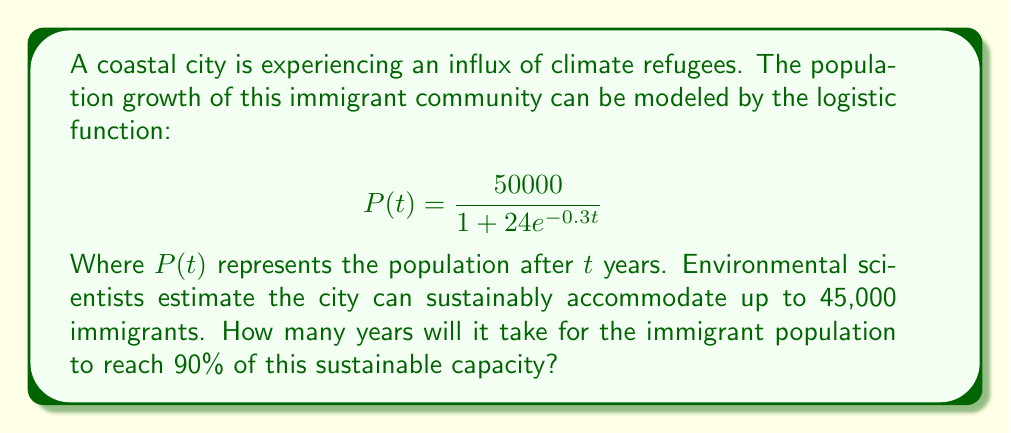Could you help me with this problem? To solve this problem, we'll follow these steps:

1) First, we need to calculate 90% of the sustainable capacity:
   $45,000 \times 0.90 = 40,500$

2) Now, we need to solve the equation:
   $$40500 = \frac{50000}{1 + 24e^{-0.3t}}$$

3) Let's isolate the exponential term:
   $$1 + 24e^{-0.3t} = \frac{50000}{40500}$$
   $$24e^{-0.3t} = \frac{50000}{40500} - 1 = 0.2346$$
   $$e^{-0.3t} = \frac{0.2346}{24} = 0.009775$$

4) Now we can take the natural logarithm of both sides:
   $$-0.3t = \ln(0.009775)$$
   $$t = \frac{\ln(0.009775)}{-0.3}$$

5) Calculating this:
   $$t = \frac{-4.6277}{-0.3} \approx 15.4257$$

6) Since we're dealing with years, we'll round up to the nearest whole year.
Answer: 16 years 